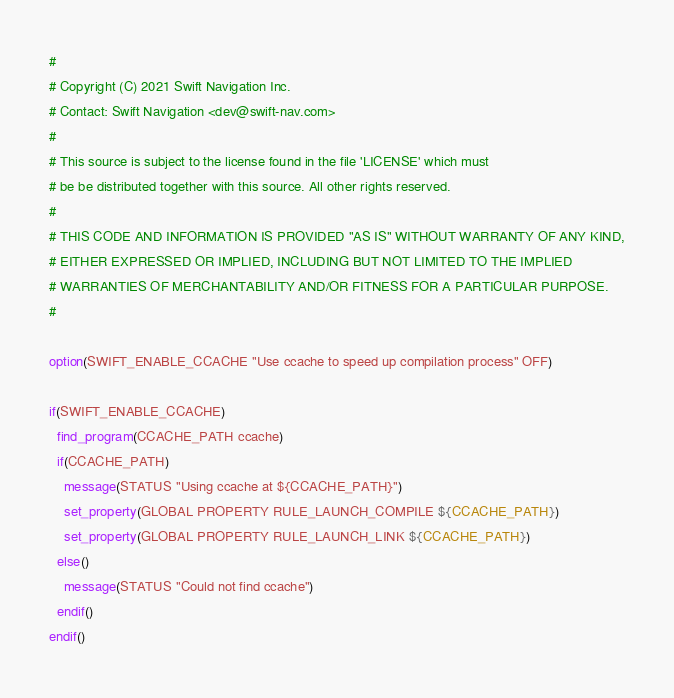Convert code to text. <code><loc_0><loc_0><loc_500><loc_500><_CMake_>#
# Copyright (C) 2021 Swift Navigation Inc.
# Contact: Swift Navigation <dev@swift-nav.com>
#
# This source is subject to the license found in the file 'LICENSE' which must
# be be distributed together with this source. All other rights reserved.
#
# THIS CODE AND INFORMATION IS PROVIDED "AS IS" WITHOUT WARRANTY OF ANY KIND,
# EITHER EXPRESSED OR IMPLIED, INCLUDING BUT NOT LIMITED TO THE IMPLIED
# WARRANTIES OF MERCHANTABILITY AND/OR FITNESS FOR A PARTICULAR PURPOSE.
#

option(SWIFT_ENABLE_CCACHE "Use ccache to speed up compilation process" OFF)

if(SWIFT_ENABLE_CCACHE)
  find_program(CCACHE_PATH ccache)
  if(CCACHE_PATH)
    message(STATUS "Using ccache at ${CCACHE_PATH}")
    set_property(GLOBAL PROPERTY RULE_LAUNCH_COMPILE ${CCACHE_PATH})
    set_property(GLOBAL PROPERTY RULE_LAUNCH_LINK ${CCACHE_PATH})
  else()
    message(STATUS "Could not find ccache")
  endif()
endif()
</code> 